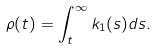Convert formula to latex. <formula><loc_0><loc_0><loc_500><loc_500>\rho ( t ) = \int _ { t } ^ { \infty } k _ { 1 } ( s ) d s .</formula> 